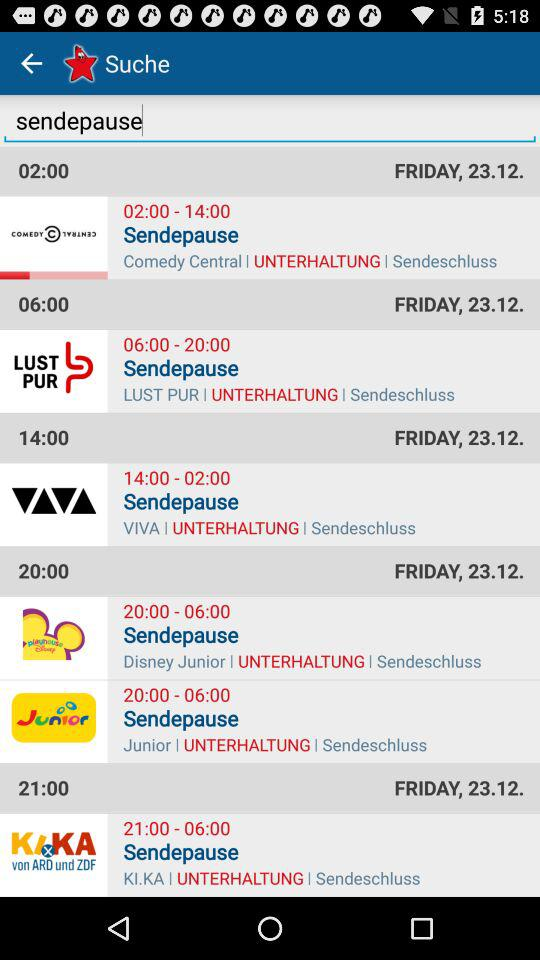What is the date of Comedy Central? The date is Friday, 23.12. 